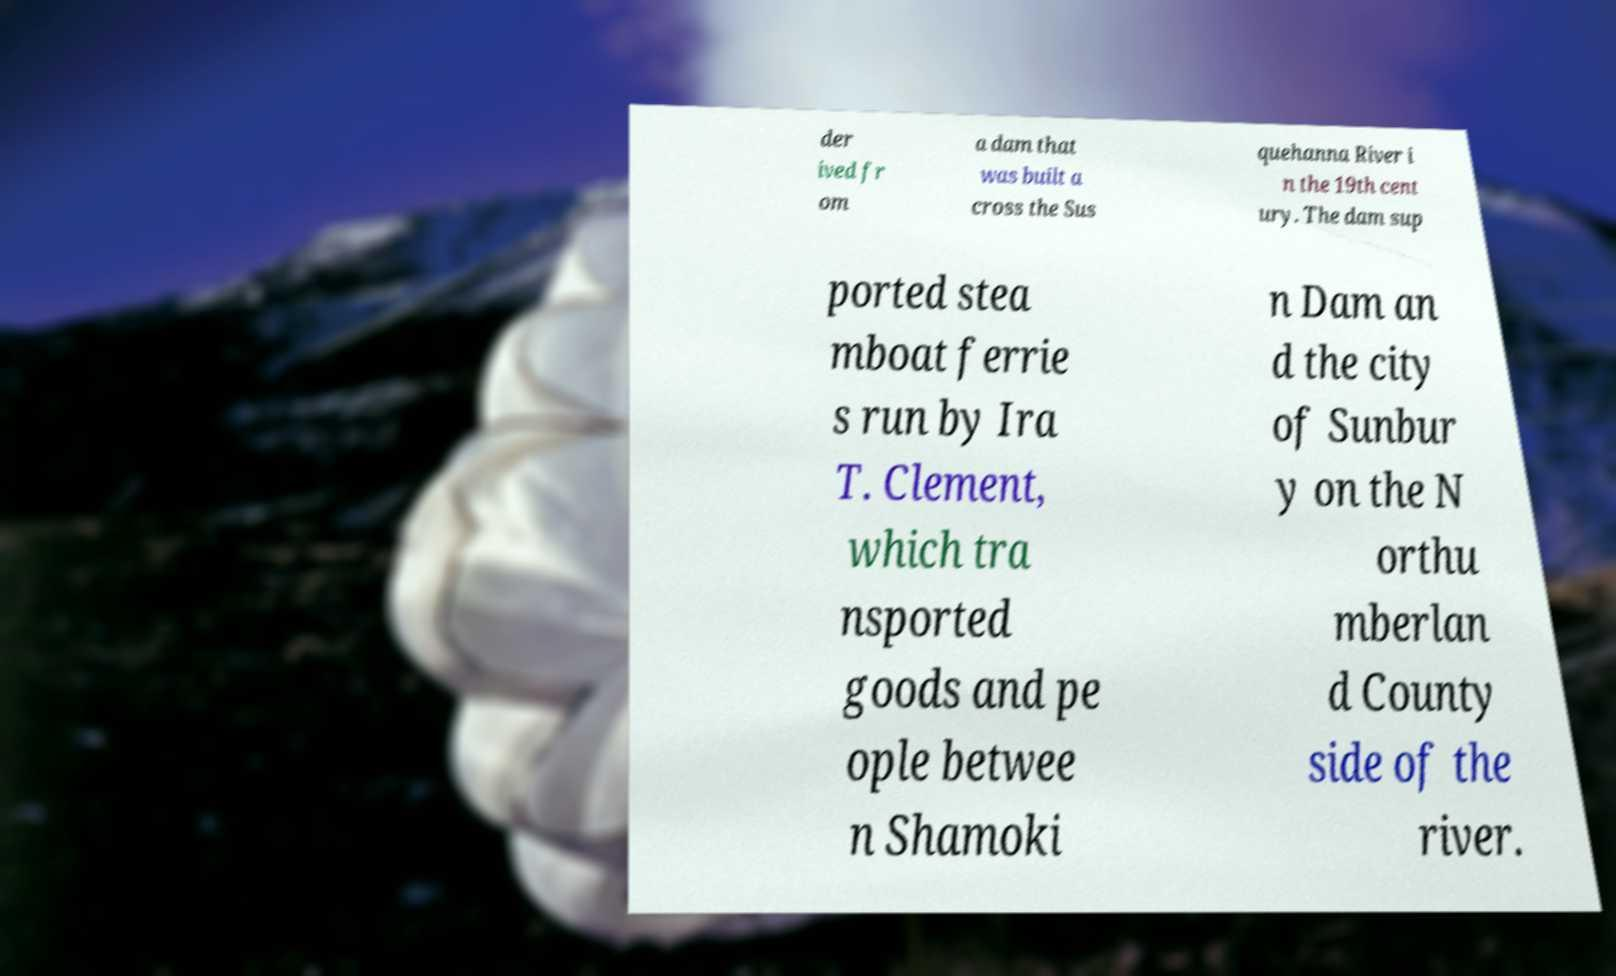Could you assist in decoding the text presented in this image and type it out clearly? der ived fr om a dam that was built a cross the Sus quehanna River i n the 19th cent ury. The dam sup ported stea mboat ferrie s run by Ira T. Clement, which tra nsported goods and pe ople betwee n Shamoki n Dam an d the city of Sunbur y on the N orthu mberlan d County side of the river. 